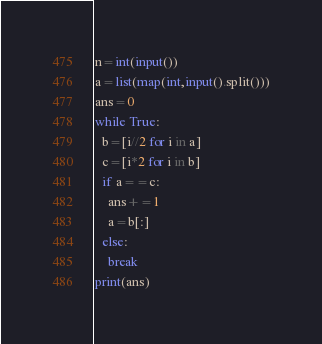Convert code to text. <code><loc_0><loc_0><loc_500><loc_500><_Python_>n=int(input())
a=list(map(int,input().split()))
ans=0
while True:
  b=[i//2 for i in a]
  c=[i*2 for i in b]
  if a==c:
    ans+=1
    a=b[:]
  else:
    break
print(ans)</code> 